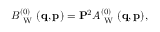<formula> <loc_0><loc_0><loc_500><loc_500>\begin{array} { r } { B _ { W } ^ { ( 0 ) } ( { q } , { p } ) = { P } ^ { 2 } A _ { W } ^ { ( 0 ) } ( { q } , { p } ) , } \end{array}</formula> 